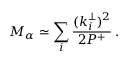<formula> <loc_0><loc_0><loc_500><loc_500>M _ { \alpha } \simeq \sum _ { i } \frac { ( k _ { i } ^ { \perp } ) ^ { 2 } } { 2 P ^ { + } } \, .</formula> 